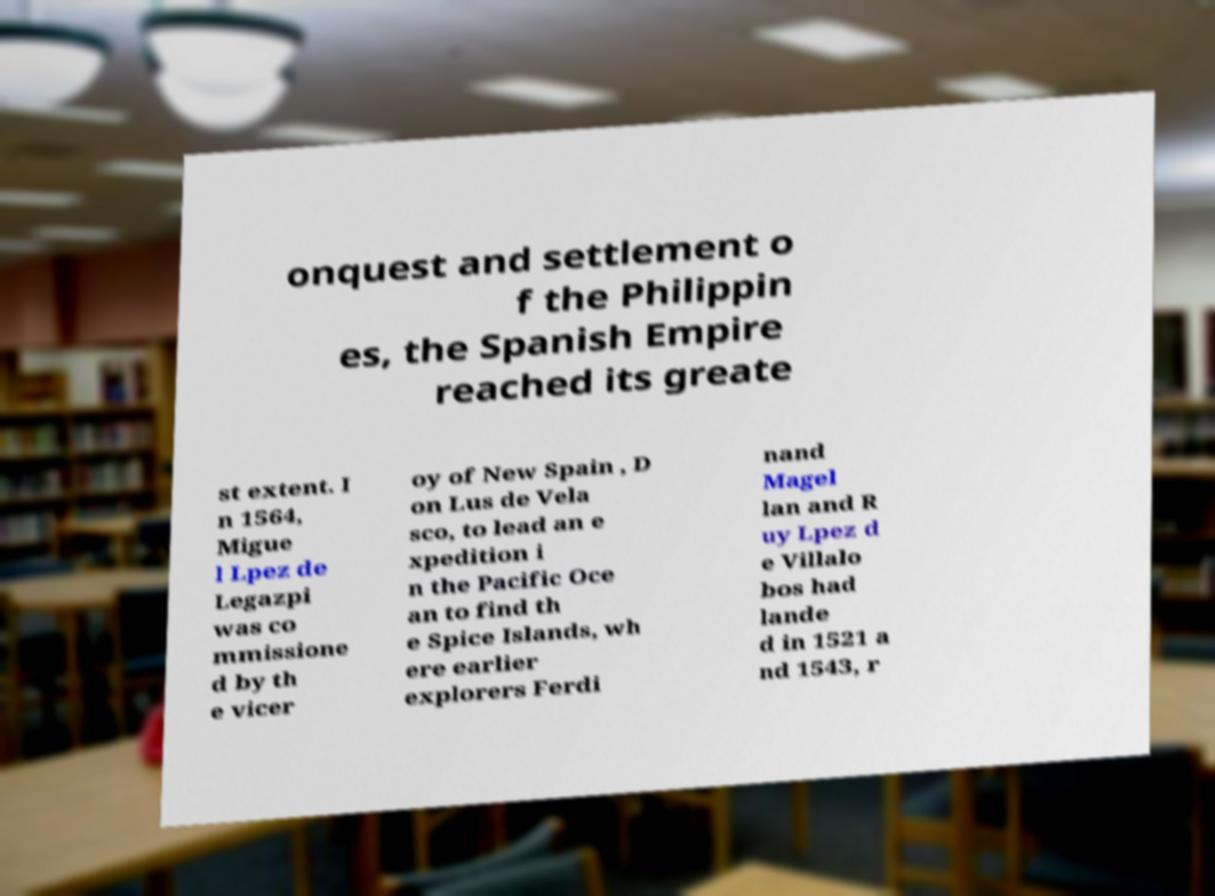Could you assist in decoding the text presented in this image and type it out clearly? onquest and settlement o f the Philippin es, the Spanish Empire reached its greate st extent. I n 1564, Migue l Lpez de Legazpi was co mmissione d by th e vicer oy of New Spain , D on Lus de Vela sco, to lead an e xpedition i n the Pacific Oce an to find th e Spice Islands, wh ere earlier explorers Ferdi nand Magel lan and R uy Lpez d e Villalo bos had lande d in 1521 a nd 1543, r 